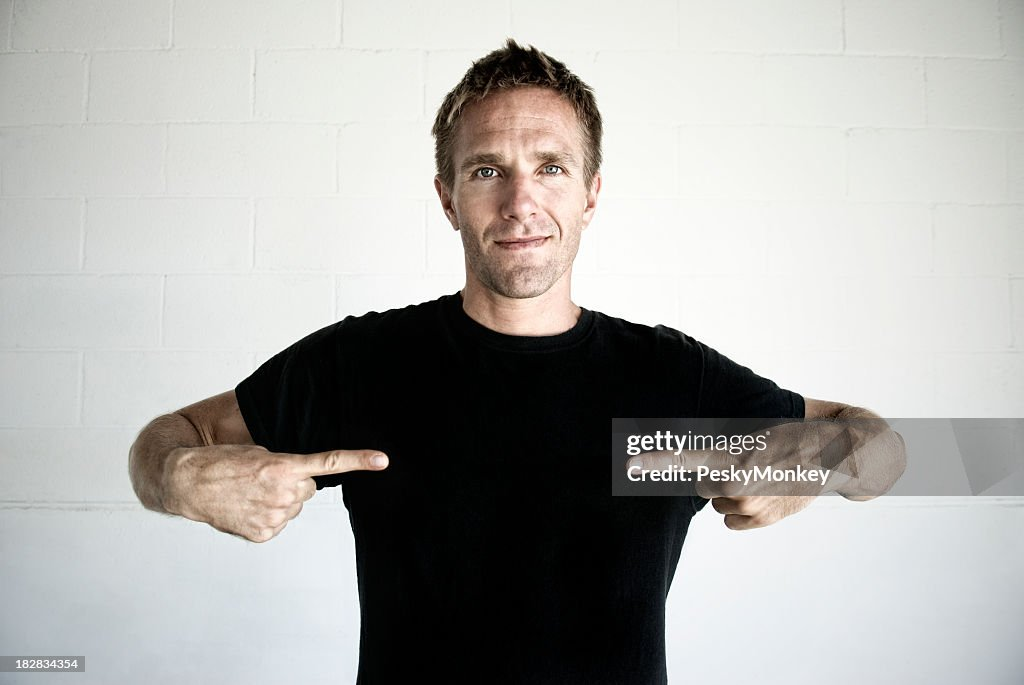What might be the context in which the man is pointing to himself, and what could he possibly be indicating or promoting? Based on the image, the man pointing to himself appears to be engaged in a gesture that draws attention to him. His casual yet confident stance, coupled with a straightforward facial expression and the neutral backdrop, could suggest he's part of an informal setting, perhaps addressing a group in a relaxed environment. It's plausible that he's conveying a personal story or emphasizing a point about himself – the gesture often signifies 'me' or 'I.' He might be at an informal talk, a casual promotional event, or representing a concept associated with identity, such as personal well-being or individuality. The lack of any logos or text on his plain shirt suggests he's not advertising a specific brand, leaving a focus on the individual rather than commercial messaging. 